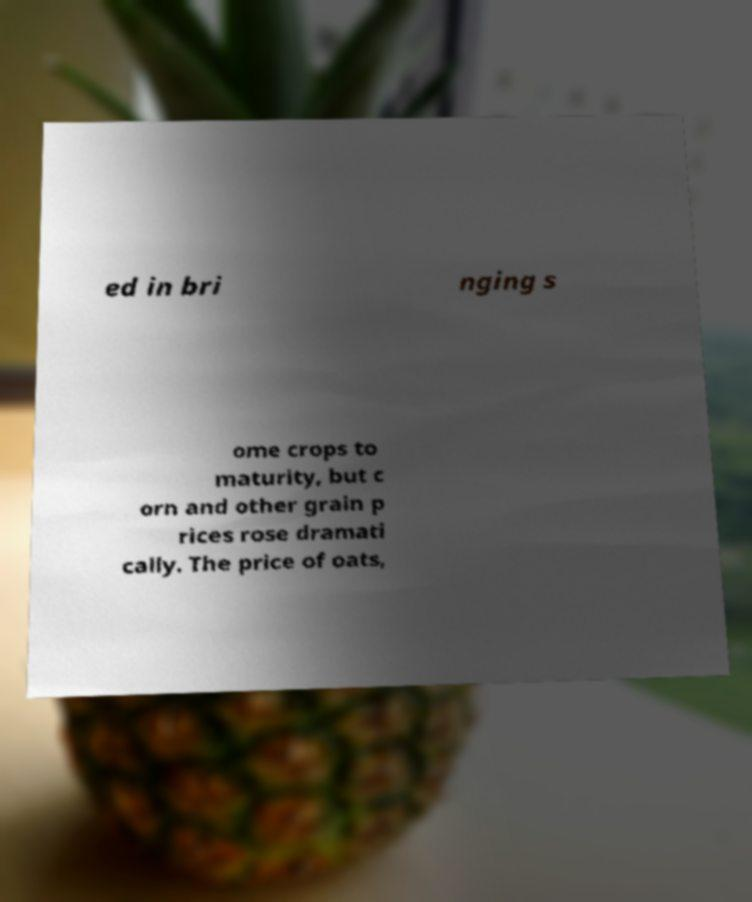What messages or text are displayed in this image? I need them in a readable, typed format. ed in bri nging s ome crops to maturity, but c orn and other grain p rices rose dramati cally. The price of oats, 